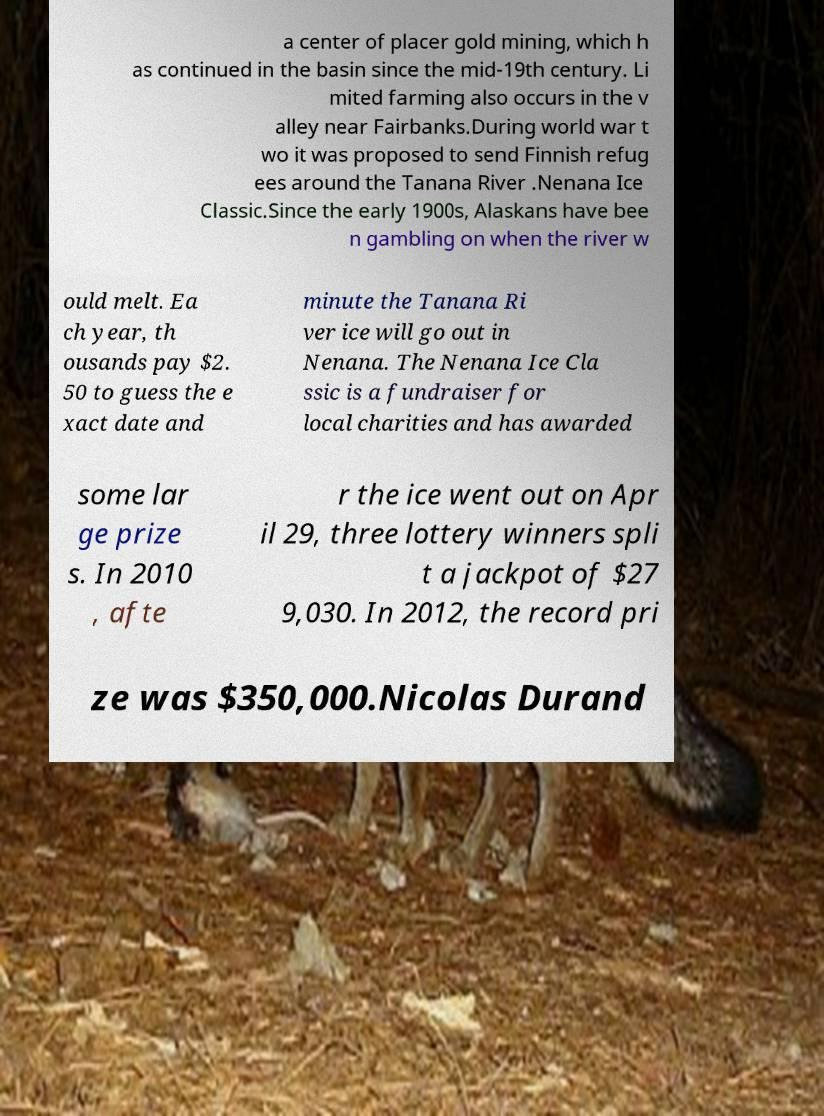Could you assist in decoding the text presented in this image and type it out clearly? a center of placer gold mining, which h as continued in the basin since the mid-19th century. Li mited farming also occurs in the v alley near Fairbanks.During world war t wo it was proposed to send Finnish refug ees around the Tanana River .Nenana Ice Classic.Since the early 1900s, Alaskans have bee n gambling on when the river w ould melt. Ea ch year, th ousands pay $2. 50 to guess the e xact date and minute the Tanana Ri ver ice will go out in Nenana. The Nenana Ice Cla ssic is a fundraiser for local charities and has awarded some lar ge prize s. In 2010 , afte r the ice went out on Apr il 29, three lottery winners spli t a jackpot of $27 9,030. In 2012, the record pri ze was $350,000.Nicolas Durand 